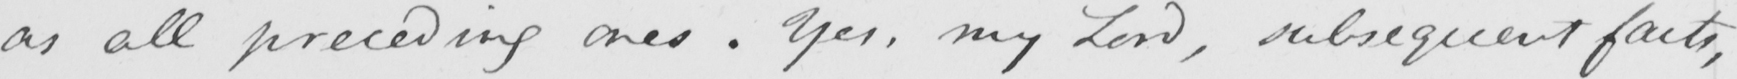Please provide the text content of this handwritten line. as all preceding ones . Yes , my Lord , subsequent facts , 